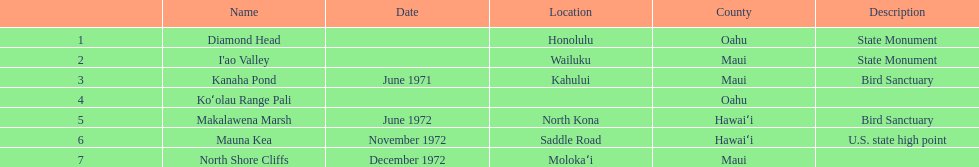What is the name of the only landmark that is also a u.s. state high point? Mauna Kea. 